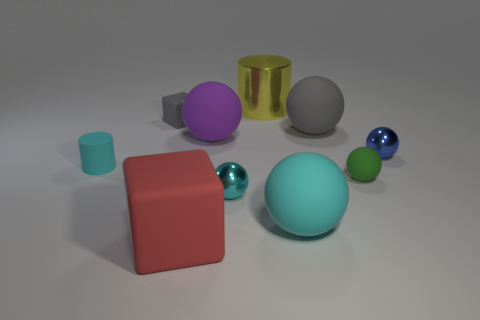Subtract all cyan balls. How many balls are left? 4 Subtract 2 balls. How many balls are left? 4 Subtract all blue metal spheres. How many spheres are left? 5 Subtract all blue spheres. Subtract all brown cylinders. How many spheres are left? 5 Subtract all blocks. How many objects are left? 8 Subtract all big gray rubber things. Subtract all purple objects. How many objects are left? 8 Add 5 metal things. How many metal things are left? 8 Add 2 gray blocks. How many gray blocks exist? 3 Subtract 1 yellow cylinders. How many objects are left? 9 